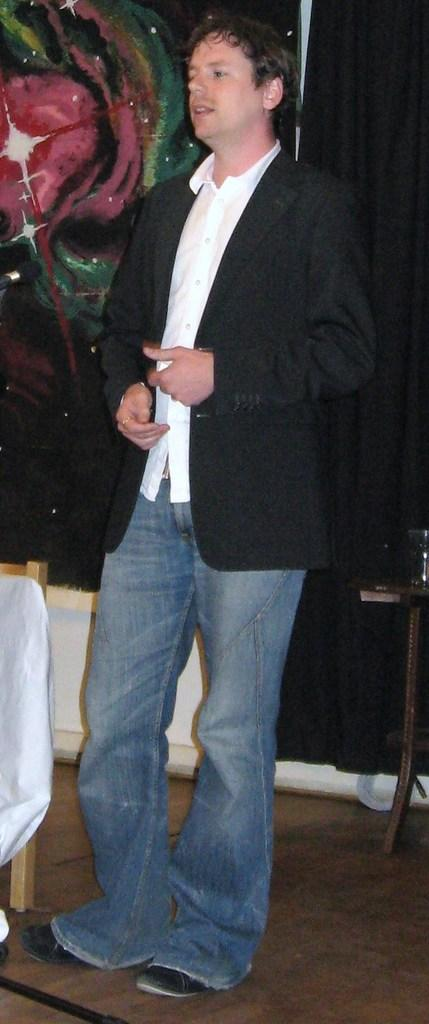What is the main subject of the image? There is a person in the image. What is the person wearing on their upper body? The person is wearing a white shirt and a black coat. What is located beside the person? There is a chair beside the person. What can be seen in the background of the image? There is a black curtain in the background of the image. Can you tell me how many creatures are interacting with the person in the image? There are no creatures present in the image; it only features a person wearing a white shirt and a black coat, a chair beside them, and a black curtain in the background. 